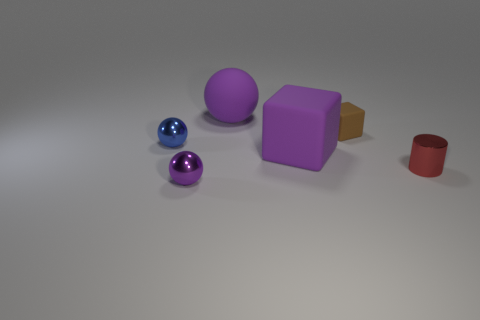Subtract all blue metal balls. How many balls are left? 2 Subtract 0 red balls. How many objects are left? 6 Subtract all cubes. How many objects are left? 4 Subtract 1 cubes. How many cubes are left? 1 Subtract all brown cubes. Subtract all green balls. How many cubes are left? 1 Subtract all purple balls. How many brown blocks are left? 1 Subtract all small metal things. Subtract all metallic objects. How many objects are left? 0 Add 1 tiny matte things. How many tiny matte things are left? 2 Add 3 purple balls. How many purple balls exist? 5 Add 1 small matte blocks. How many objects exist? 7 